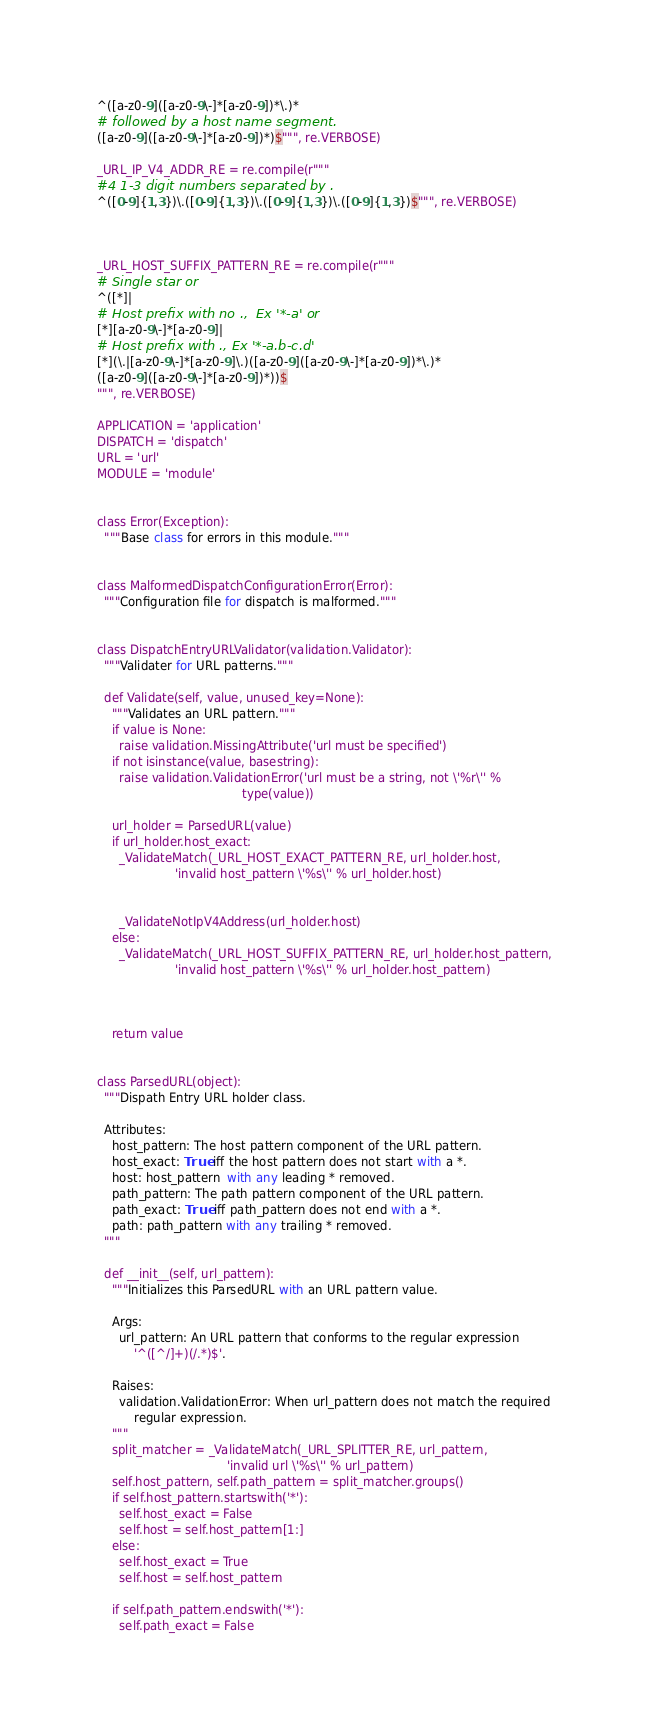<code> <loc_0><loc_0><loc_500><loc_500><_Python_>^([a-z0-9]([a-z0-9\-]*[a-z0-9])*\.)*
# followed by a host name segment.
([a-z0-9]([a-z0-9\-]*[a-z0-9])*)$""", re.VERBOSE)

_URL_IP_V4_ADDR_RE = re.compile(r"""
#4 1-3 digit numbers separated by .
^([0-9]{1,3})\.([0-9]{1,3})\.([0-9]{1,3})\.([0-9]{1,3})$""", re.VERBOSE)



_URL_HOST_SUFFIX_PATTERN_RE = re.compile(r"""
# Single star or
^([*]|
# Host prefix with no .,  Ex '*-a' or
[*][a-z0-9\-]*[a-z0-9]|
# Host prefix with ., Ex '*-a.b-c.d'
[*](\.|[a-z0-9\-]*[a-z0-9]\.)([a-z0-9]([a-z0-9\-]*[a-z0-9])*\.)*
([a-z0-9]([a-z0-9\-]*[a-z0-9])*))$
""", re.VERBOSE)

APPLICATION = 'application'
DISPATCH = 'dispatch'
URL = 'url'
MODULE = 'module'


class Error(Exception):
  """Base class for errors in this module."""


class MalformedDispatchConfigurationError(Error):
  """Configuration file for dispatch is malformed."""


class DispatchEntryURLValidator(validation.Validator):
  """Validater for URL patterns."""

  def Validate(self, value, unused_key=None):
    """Validates an URL pattern."""
    if value is None:
      raise validation.MissingAttribute('url must be specified')
    if not isinstance(value, basestring):
      raise validation.ValidationError('url must be a string, not \'%r\'' %
                                       type(value))

    url_holder = ParsedURL(value)
    if url_holder.host_exact:
      _ValidateMatch(_URL_HOST_EXACT_PATTERN_RE, url_holder.host,
                     'invalid host_pattern \'%s\'' % url_holder.host)


      _ValidateNotIpV4Address(url_holder.host)
    else:
      _ValidateMatch(_URL_HOST_SUFFIX_PATTERN_RE, url_holder.host_pattern,
                     'invalid host_pattern \'%s\'' % url_holder.host_pattern)



    return value


class ParsedURL(object):
  """Dispath Entry URL holder class.

  Attributes:
    host_pattern: The host pattern component of the URL pattern.
    host_exact: True iff the host pattern does not start with a *.
    host: host_pattern  with any leading * removed.
    path_pattern: The path pattern component of the URL pattern.
    path_exact: True iff path_pattern does not end with a *.
    path: path_pattern with any trailing * removed.
  """

  def __init__(self, url_pattern):
    """Initializes this ParsedURL with an URL pattern value.

    Args:
      url_pattern: An URL pattern that conforms to the regular expression
          '^([^/]+)(/.*)$'.

    Raises:
      validation.ValidationError: When url_pattern does not match the required
          regular expression.
    """
    split_matcher = _ValidateMatch(_URL_SPLITTER_RE, url_pattern,
                                   'invalid url \'%s\'' % url_pattern)
    self.host_pattern, self.path_pattern = split_matcher.groups()
    if self.host_pattern.startswith('*'):
      self.host_exact = False
      self.host = self.host_pattern[1:]
    else:
      self.host_exact = True
      self.host = self.host_pattern

    if self.path_pattern.endswith('*'):
      self.path_exact = False</code> 